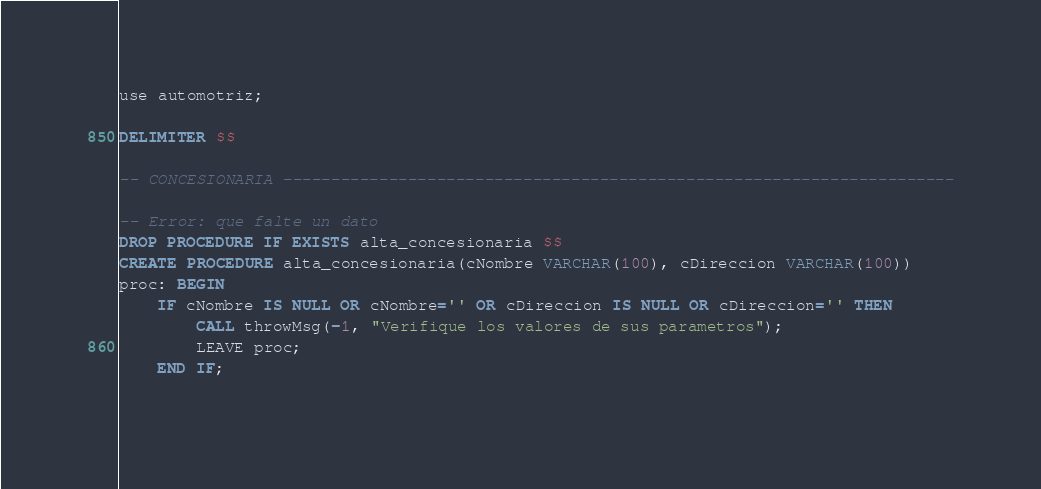<code> <loc_0><loc_0><loc_500><loc_500><_SQL_>use automotriz;

DELIMITER $$

-- CONCESIONARIA ----------------------------------------------------------------------

-- Error: que falte un dato
DROP PROCEDURE IF EXISTS alta_concesionaria $$ 
CREATE PROCEDURE alta_concesionaria(cNombre VARCHAR(100), cDireccion VARCHAR(100))
proc: BEGIN
	IF cNombre IS NULL OR cNombre='' OR cDireccion IS NULL OR cDireccion='' THEN
		CALL throwMsg(-1, "Verifique los valores de sus parametros");
        LEAVE proc;
	END IF;
	</code> 